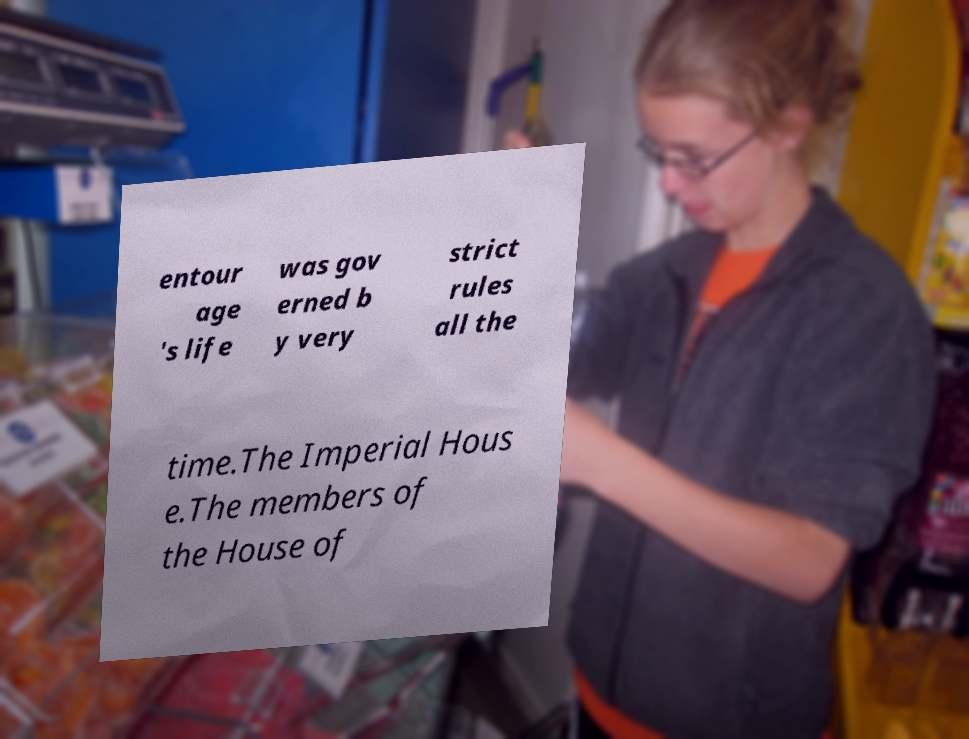Could you extract and type out the text from this image? entour age 's life was gov erned b y very strict rules all the time.The Imperial Hous e.The members of the House of 